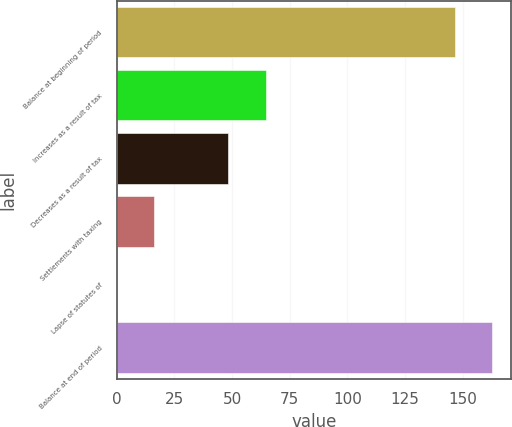<chart> <loc_0><loc_0><loc_500><loc_500><bar_chart><fcel>Balance at beginning of period<fcel>Increases as a result of tax<fcel>Decreases as a result of tax<fcel>Settlements with taxing<fcel>Lapse of statutes of<fcel>Balance at end of period<nl><fcel>146.7<fcel>64.52<fcel>48.44<fcel>16.28<fcel>0.2<fcel>162.78<nl></chart> 